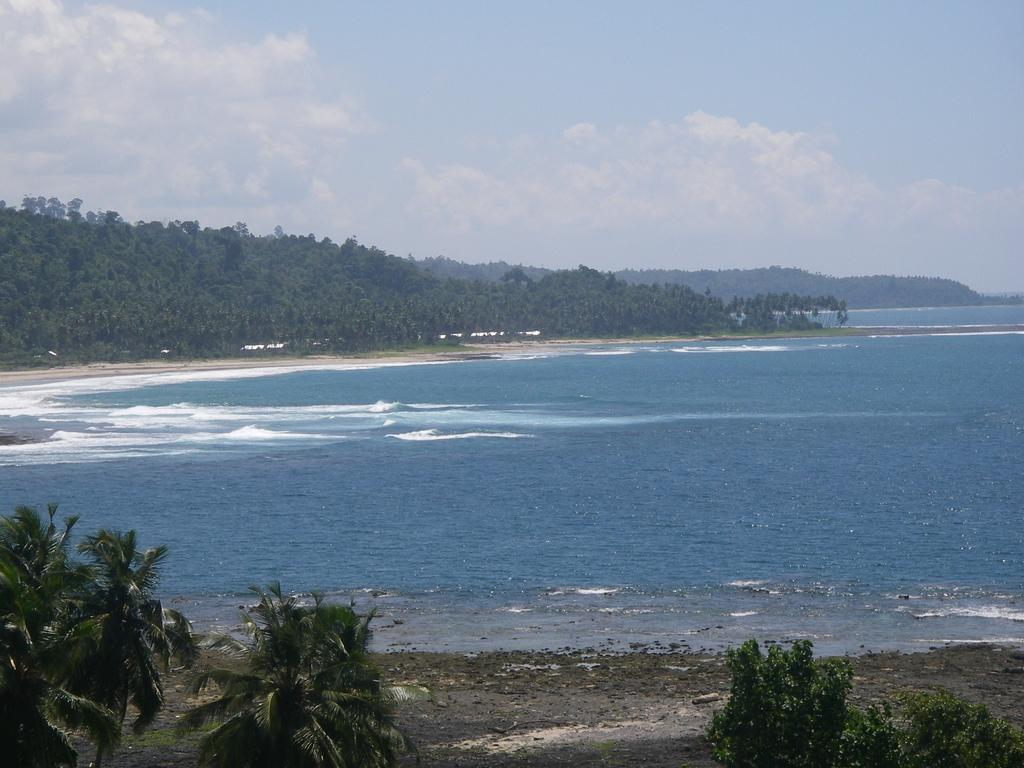What type of vegetation can be seen in the image? There are trees in the image. What part of the natural environment is visible in the image? The ground and water are visible in the image. What can be seen in the background of the image? In the background, there are mountains, more trees, the ground, water, and the sky. What type of glue is being used to hold the sun in the image? There is no sun or glue present in the image. 